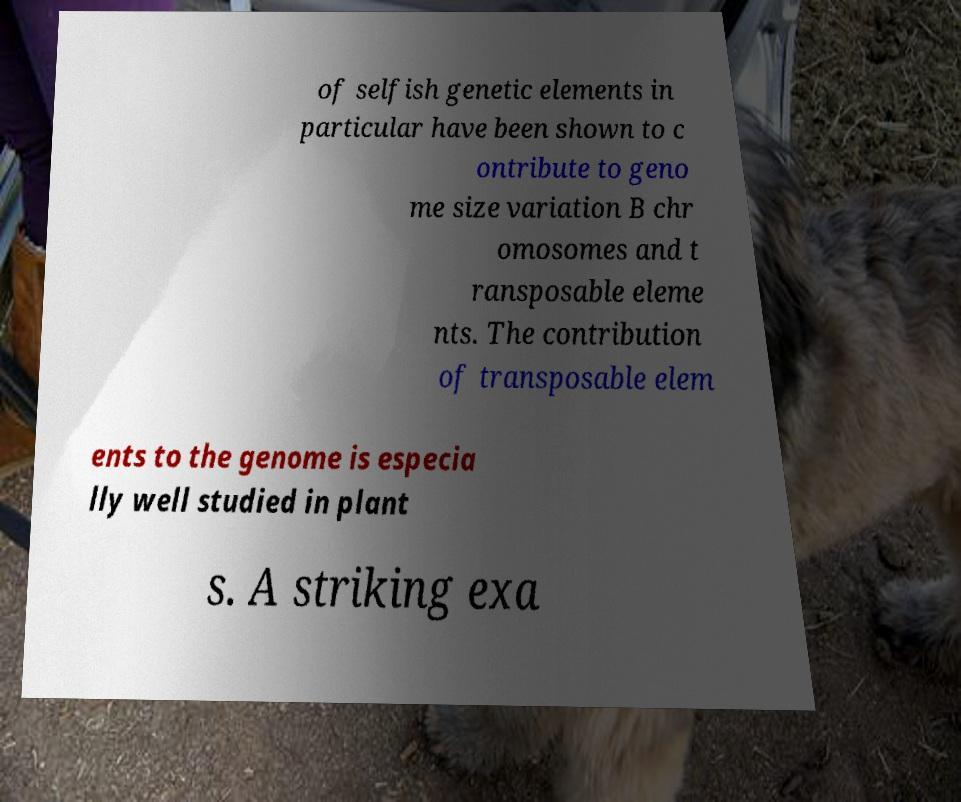Please identify and transcribe the text found in this image. of selfish genetic elements in particular have been shown to c ontribute to geno me size variation B chr omosomes and t ransposable eleme nts. The contribution of transposable elem ents to the genome is especia lly well studied in plant s. A striking exa 